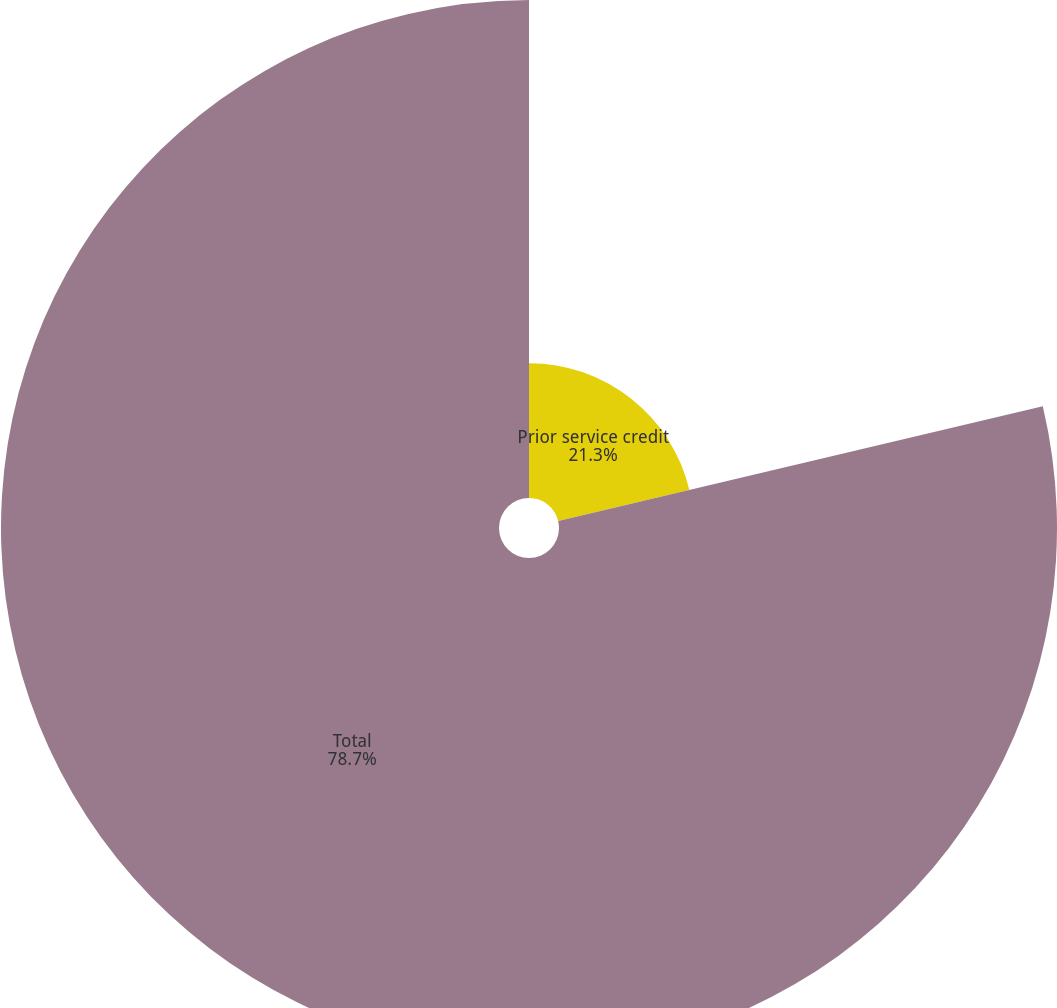<chart> <loc_0><loc_0><loc_500><loc_500><pie_chart><fcel>Prior service credit<fcel>Total<nl><fcel>21.3%<fcel>78.7%<nl></chart> 